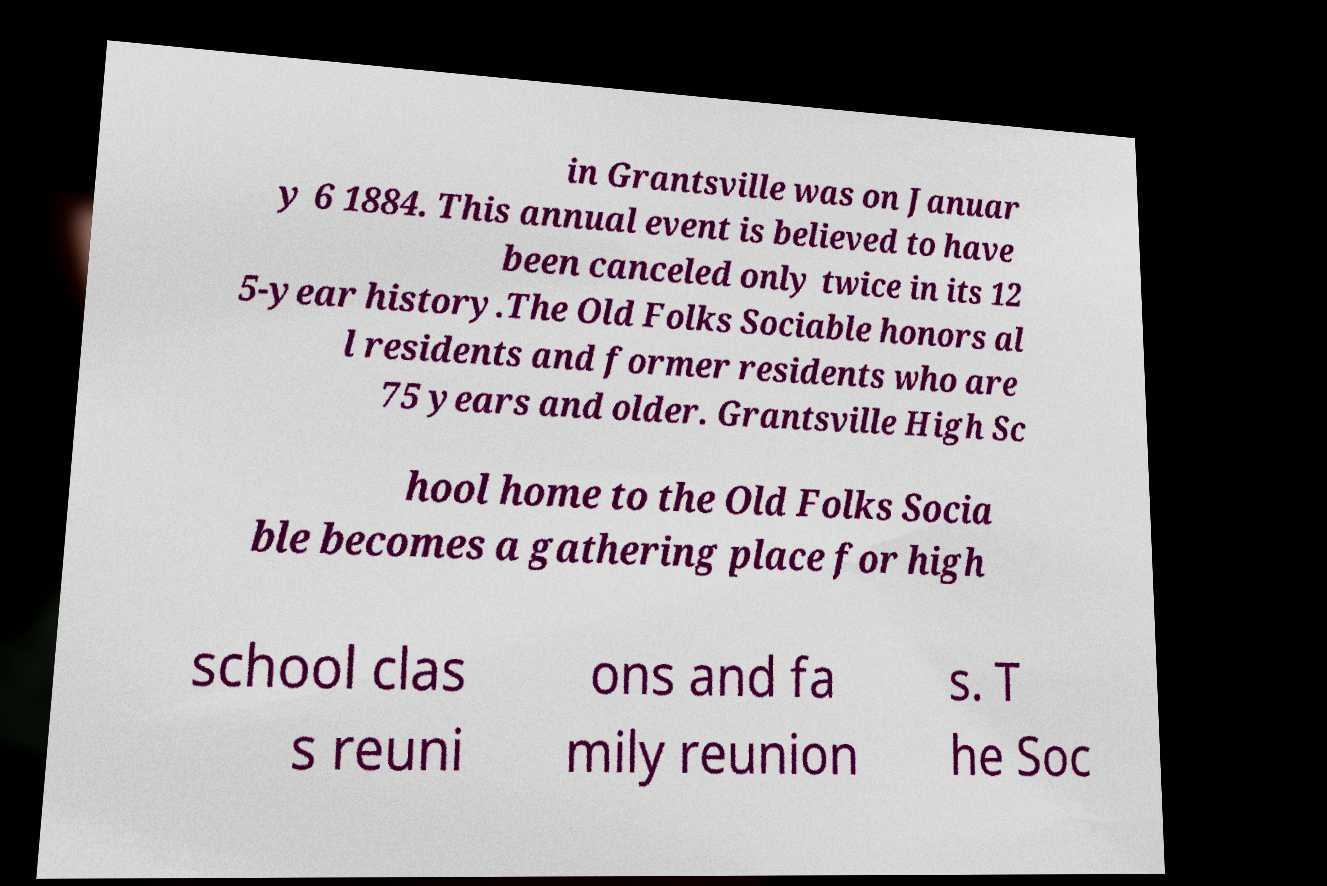Could you extract and type out the text from this image? in Grantsville was on Januar y 6 1884. This annual event is believed to have been canceled only twice in its 12 5-year history.The Old Folks Sociable honors al l residents and former residents who are 75 years and older. Grantsville High Sc hool home to the Old Folks Socia ble becomes a gathering place for high school clas s reuni ons and fa mily reunion s. T he Soc 